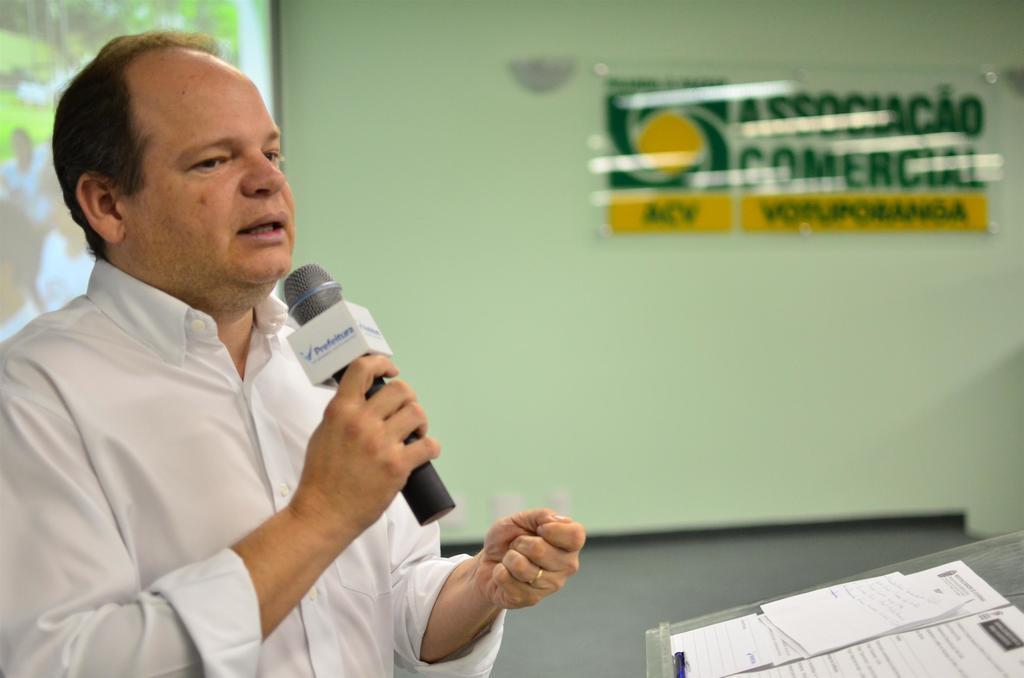In one or two sentences, can you explain what this image depicts? In the picture on the left a man is talking something into the microphone. On the right there is table, on the table there are papers. On top right there is a board. On the top left there is a screen. 